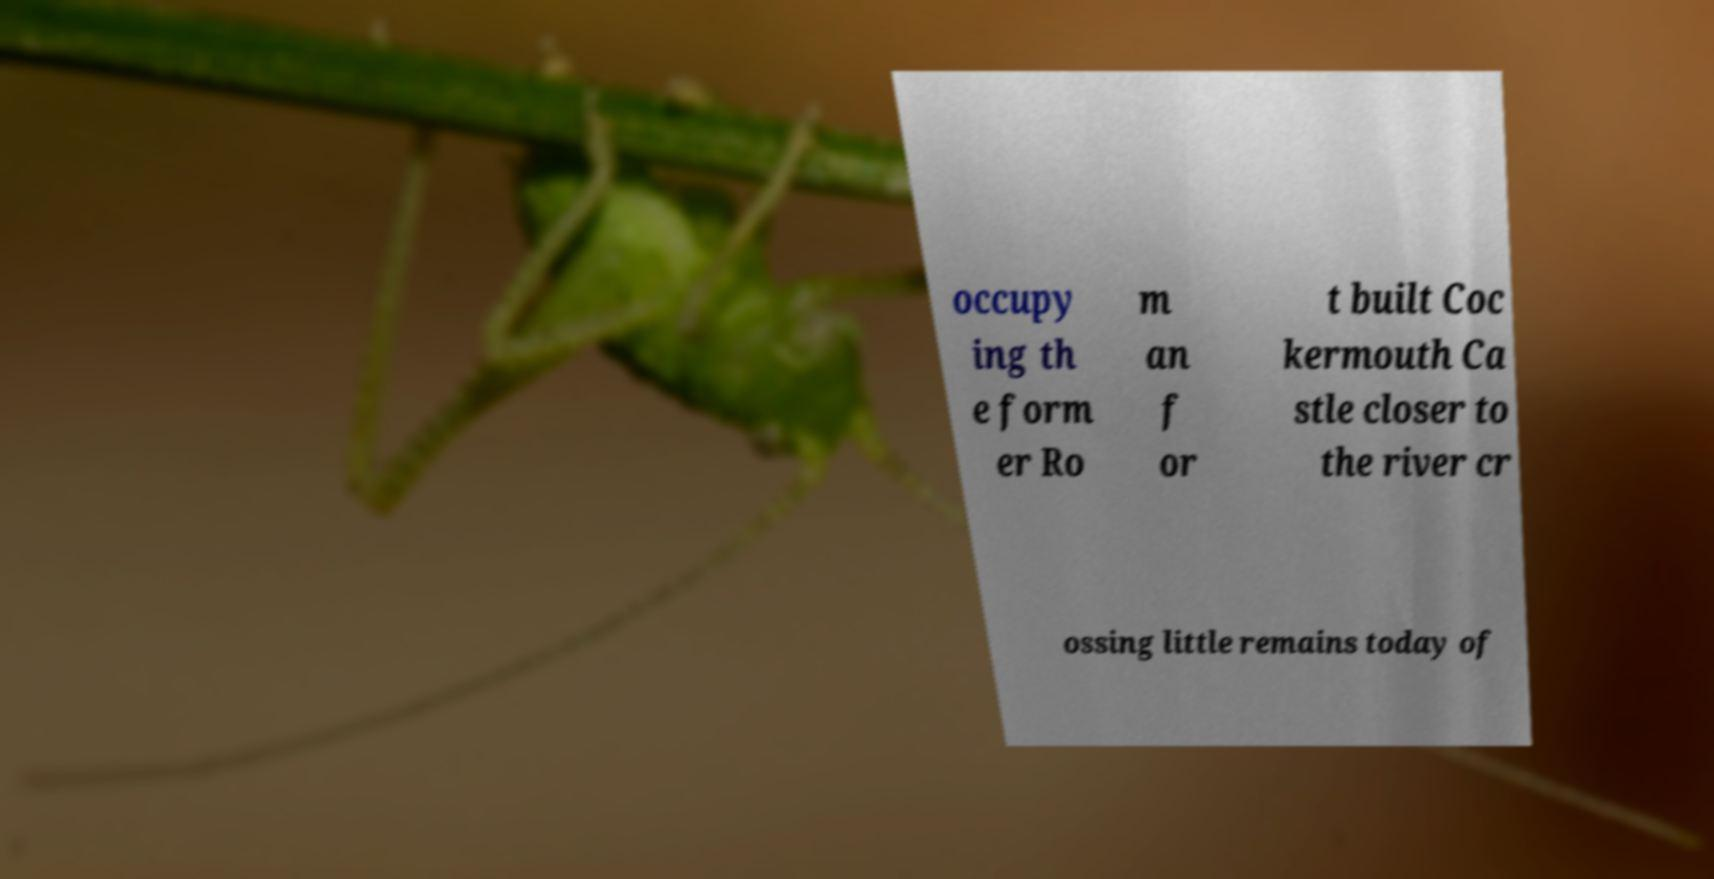Can you accurately transcribe the text from the provided image for me? occupy ing th e form er Ro m an f or t built Coc kermouth Ca stle closer to the river cr ossing little remains today of 